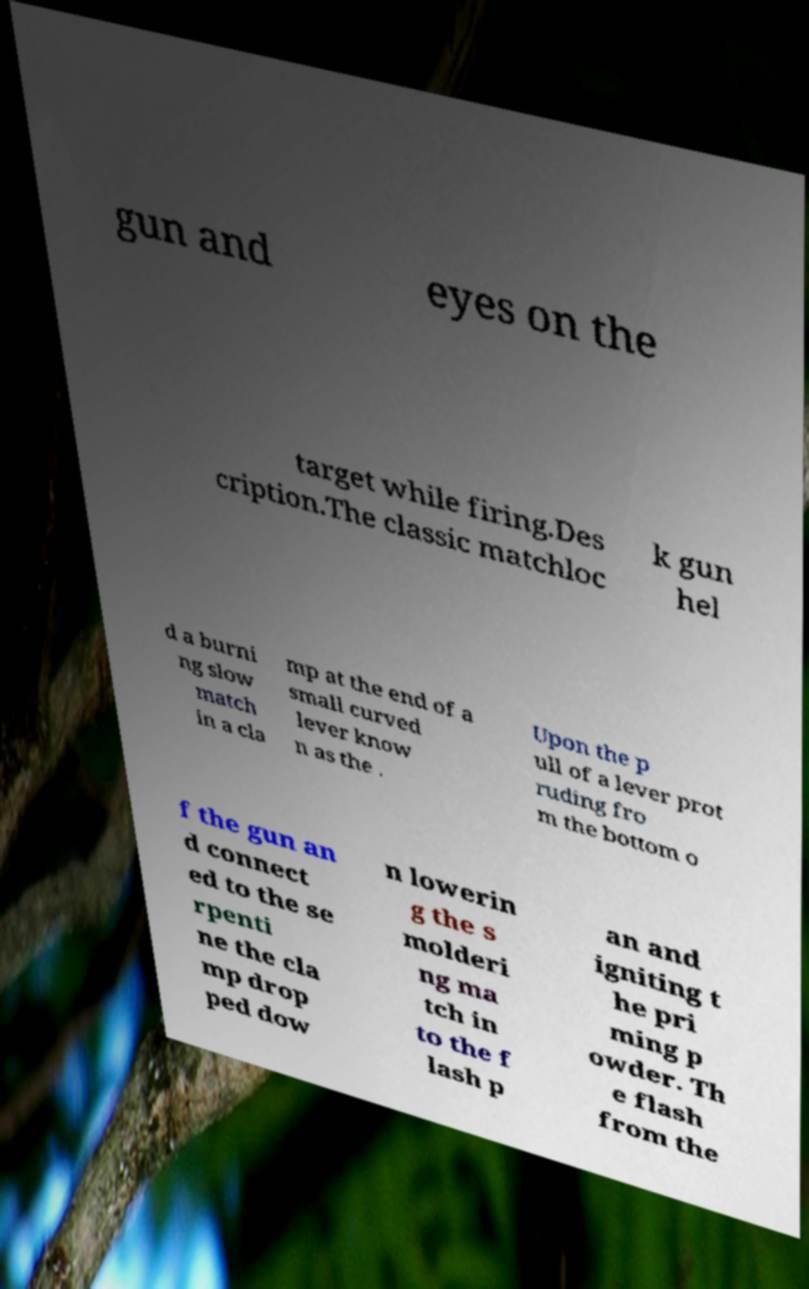There's text embedded in this image that I need extracted. Can you transcribe it verbatim? gun and eyes on the target while firing.Des cription.The classic matchloc k gun hel d a burni ng slow match in a cla mp at the end of a small curved lever know n as the . Upon the p ull of a lever prot ruding fro m the bottom o f the gun an d connect ed to the se rpenti ne the cla mp drop ped dow n lowerin g the s molderi ng ma tch in to the f lash p an and igniting t he pri ming p owder. Th e flash from the 